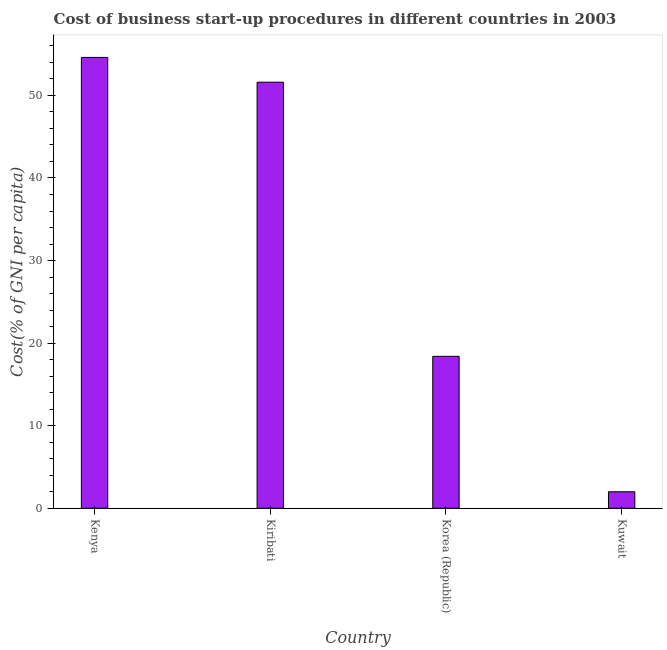What is the title of the graph?
Make the answer very short. Cost of business start-up procedures in different countries in 2003. What is the label or title of the Y-axis?
Your answer should be compact. Cost(% of GNI per capita). What is the cost of business startup procedures in Kiribati?
Make the answer very short. 51.6. Across all countries, what is the maximum cost of business startup procedures?
Offer a terse response. 54.6. In which country was the cost of business startup procedures maximum?
Provide a short and direct response. Kenya. In which country was the cost of business startup procedures minimum?
Offer a very short reply. Kuwait. What is the sum of the cost of business startup procedures?
Provide a short and direct response. 126.6. What is the difference between the cost of business startup procedures in Korea (Republic) and Kuwait?
Ensure brevity in your answer.  16.4. What is the average cost of business startup procedures per country?
Offer a terse response. 31.65. In how many countries, is the cost of business startup procedures greater than 14 %?
Your answer should be compact. 3. What is the ratio of the cost of business startup procedures in Korea (Republic) to that in Kuwait?
Give a very brief answer. 9.2. What is the difference between the highest and the second highest cost of business startup procedures?
Your response must be concise. 3. What is the difference between the highest and the lowest cost of business startup procedures?
Your answer should be compact. 52.6. In how many countries, is the cost of business startup procedures greater than the average cost of business startup procedures taken over all countries?
Offer a terse response. 2. Are all the bars in the graph horizontal?
Provide a short and direct response. No. How many countries are there in the graph?
Your response must be concise. 4. Are the values on the major ticks of Y-axis written in scientific E-notation?
Your answer should be compact. No. What is the Cost(% of GNI per capita) of Kenya?
Provide a succinct answer. 54.6. What is the Cost(% of GNI per capita) in Kiribati?
Provide a short and direct response. 51.6. What is the difference between the Cost(% of GNI per capita) in Kenya and Kiribati?
Your answer should be very brief. 3. What is the difference between the Cost(% of GNI per capita) in Kenya and Korea (Republic)?
Ensure brevity in your answer.  36.2. What is the difference between the Cost(% of GNI per capita) in Kenya and Kuwait?
Provide a short and direct response. 52.6. What is the difference between the Cost(% of GNI per capita) in Kiribati and Korea (Republic)?
Your answer should be very brief. 33.2. What is the difference between the Cost(% of GNI per capita) in Kiribati and Kuwait?
Offer a terse response. 49.6. What is the difference between the Cost(% of GNI per capita) in Korea (Republic) and Kuwait?
Your answer should be compact. 16.4. What is the ratio of the Cost(% of GNI per capita) in Kenya to that in Kiribati?
Make the answer very short. 1.06. What is the ratio of the Cost(% of GNI per capita) in Kenya to that in Korea (Republic)?
Provide a succinct answer. 2.97. What is the ratio of the Cost(% of GNI per capita) in Kenya to that in Kuwait?
Your answer should be compact. 27.3. What is the ratio of the Cost(% of GNI per capita) in Kiribati to that in Korea (Republic)?
Ensure brevity in your answer.  2.8. What is the ratio of the Cost(% of GNI per capita) in Kiribati to that in Kuwait?
Keep it short and to the point. 25.8. What is the ratio of the Cost(% of GNI per capita) in Korea (Republic) to that in Kuwait?
Provide a succinct answer. 9.2. 